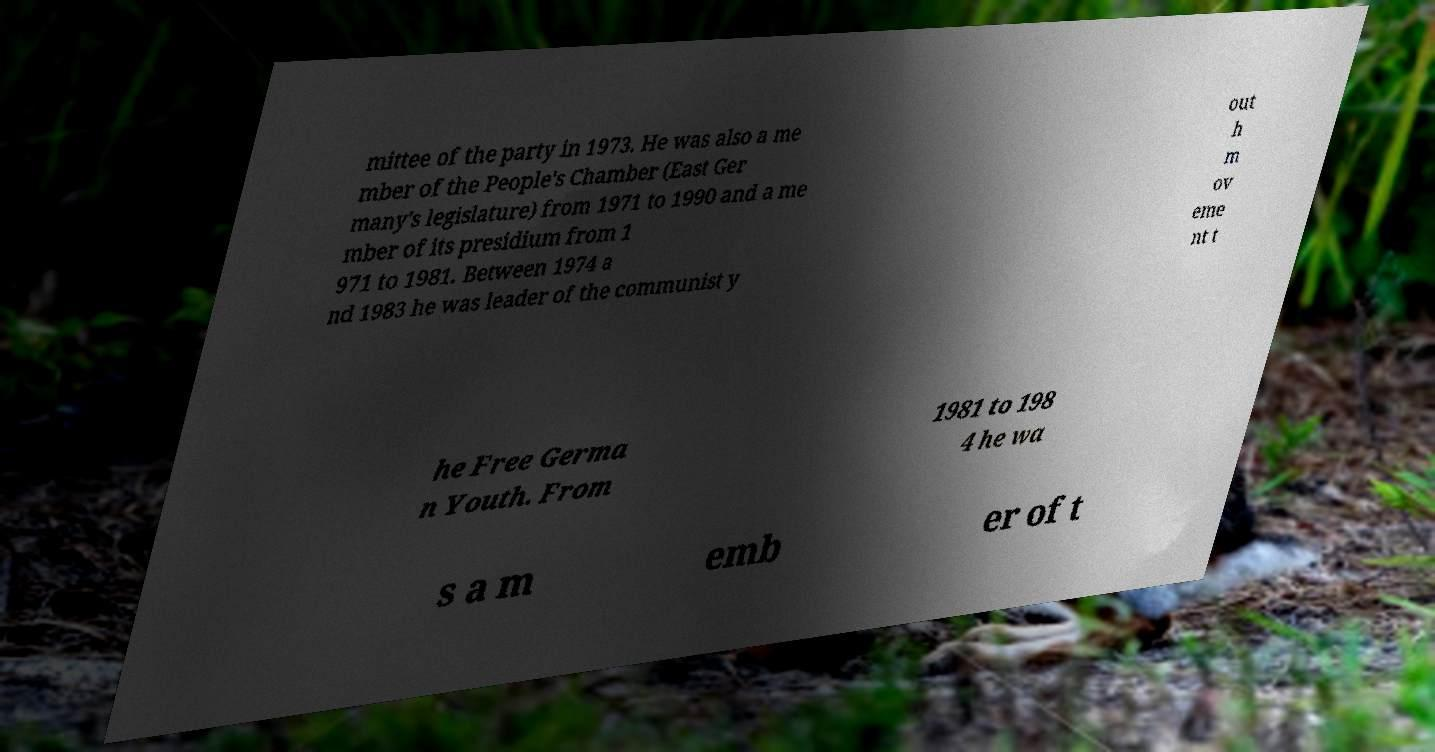Please read and relay the text visible in this image. What does it say? mittee of the party in 1973. He was also a me mber of the People's Chamber (East Ger many's legislature) from 1971 to 1990 and a me mber of its presidium from 1 971 to 1981. Between 1974 a nd 1983 he was leader of the communist y out h m ov eme nt t he Free Germa n Youth. From 1981 to 198 4 he wa s a m emb er of t 